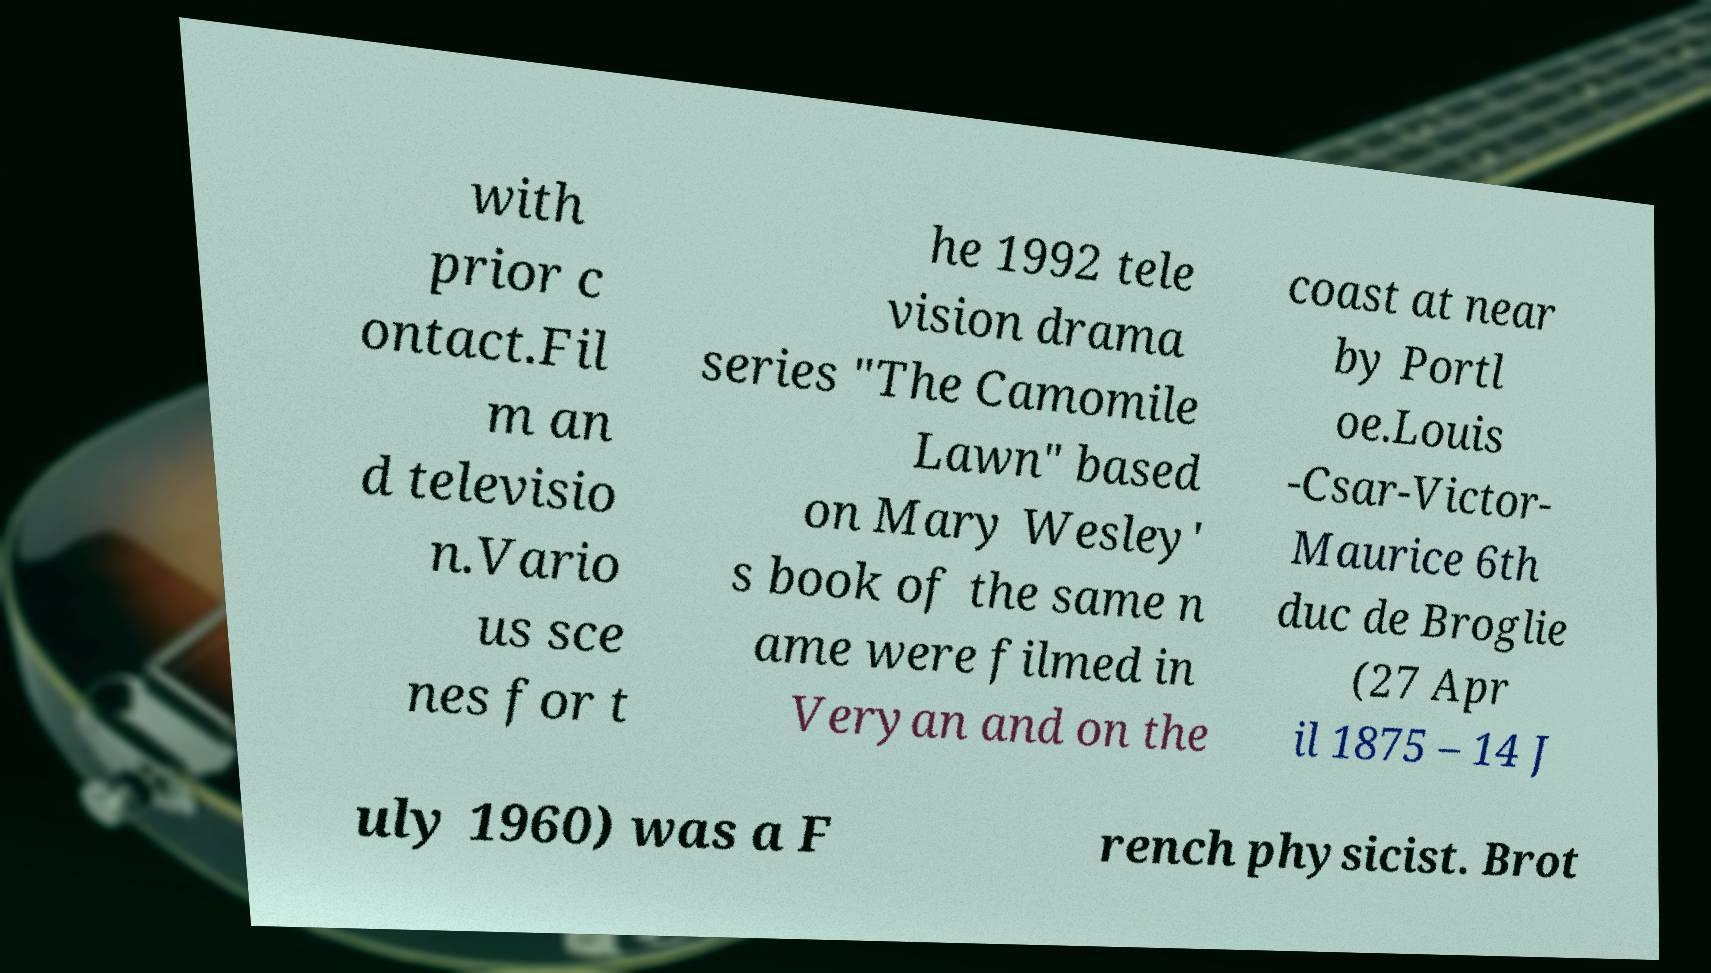Could you extract and type out the text from this image? with prior c ontact.Fil m an d televisio n.Vario us sce nes for t he 1992 tele vision drama series "The Camomile Lawn" based on Mary Wesley' s book of the same n ame were filmed in Veryan and on the coast at near by Portl oe.Louis -Csar-Victor- Maurice 6th duc de Broglie (27 Apr il 1875 – 14 J uly 1960) was a F rench physicist. Brot 